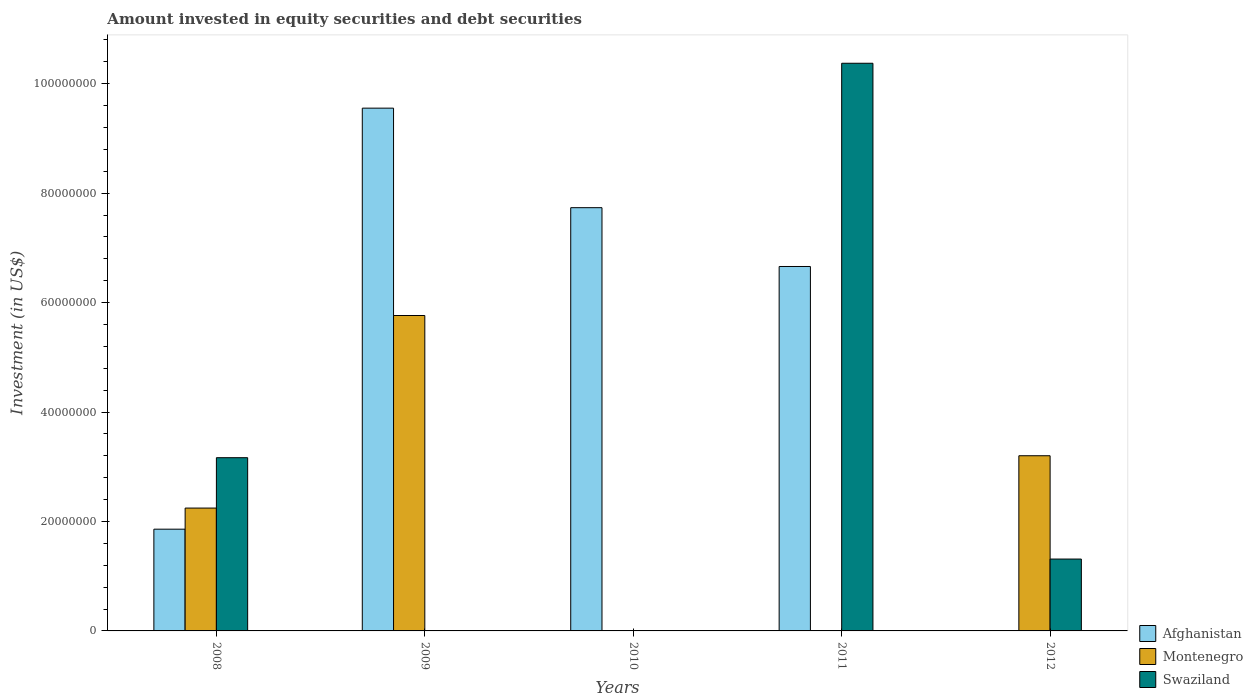How many different coloured bars are there?
Your answer should be very brief. 3. How many bars are there on the 1st tick from the left?
Keep it short and to the point. 3. How many bars are there on the 4th tick from the right?
Offer a terse response. 2. What is the amount invested in equity securities and debt securities in Swaziland in 2011?
Ensure brevity in your answer.  1.04e+08. Across all years, what is the maximum amount invested in equity securities and debt securities in Montenegro?
Ensure brevity in your answer.  5.76e+07. In which year was the amount invested in equity securities and debt securities in Montenegro maximum?
Your response must be concise. 2009. What is the total amount invested in equity securities and debt securities in Swaziland in the graph?
Offer a very short reply. 1.49e+08. What is the difference between the amount invested in equity securities and debt securities in Swaziland in 2008 and that in 2011?
Your response must be concise. -7.21e+07. What is the difference between the amount invested in equity securities and debt securities in Swaziland in 2011 and the amount invested in equity securities and debt securities in Montenegro in 2010?
Make the answer very short. 1.04e+08. What is the average amount invested in equity securities and debt securities in Swaziland per year?
Make the answer very short. 2.97e+07. In the year 2009, what is the difference between the amount invested in equity securities and debt securities in Montenegro and amount invested in equity securities and debt securities in Afghanistan?
Keep it short and to the point. -3.79e+07. What is the ratio of the amount invested in equity securities and debt securities in Swaziland in 2008 to that in 2011?
Give a very brief answer. 0.31. Is the amount invested in equity securities and debt securities in Swaziland in 2011 less than that in 2012?
Make the answer very short. No. Is the difference between the amount invested in equity securities and debt securities in Montenegro in 2008 and 2009 greater than the difference between the amount invested in equity securities and debt securities in Afghanistan in 2008 and 2009?
Give a very brief answer. Yes. What is the difference between the highest and the second highest amount invested in equity securities and debt securities in Swaziland?
Your response must be concise. 7.21e+07. What is the difference between the highest and the lowest amount invested in equity securities and debt securities in Afghanistan?
Your response must be concise. 9.55e+07. Is the sum of the amount invested in equity securities and debt securities in Montenegro in 2009 and 2012 greater than the maximum amount invested in equity securities and debt securities in Afghanistan across all years?
Provide a short and direct response. No. Are the values on the major ticks of Y-axis written in scientific E-notation?
Your answer should be very brief. No. What is the title of the graph?
Your answer should be compact. Amount invested in equity securities and debt securities. What is the label or title of the X-axis?
Make the answer very short. Years. What is the label or title of the Y-axis?
Ensure brevity in your answer.  Investment (in US$). What is the Investment (in US$) in Afghanistan in 2008?
Give a very brief answer. 1.86e+07. What is the Investment (in US$) of Montenegro in 2008?
Offer a very short reply. 2.25e+07. What is the Investment (in US$) in Swaziland in 2008?
Make the answer very short. 3.17e+07. What is the Investment (in US$) of Afghanistan in 2009?
Ensure brevity in your answer.  9.55e+07. What is the Investment (in US$) in Montenegro in 2009?
Provide a succinct answer. 5.76e+07. What is the Investment (in US$) in Afghanistan in 2010?
Ensure brevity in your answer.  7.73e+07. What is the Investment (in US$) of Afghanistan in 2011?
Make the answer very short. 6.66e+07. What is the Investment (in US$) in Swaziland in 2011?
Give a very brief answer. 1.04e+08. What is the Investment (in US$) of Montenegro in 2012?
Offer a very short reply. 3.20e+07. What is the Investment (in US$) of Swaziland in 2012?
Offer a very short reply. 1.31e+07. Across all years, what is the maximum Investment (in US$) in Afghanistan?
Offer a terse response. 9.55e+07. Across all years, what is the maximum Investment (in US$) in Montenegro?
Offer a very short reply. 5.76e+07. Across all years, what is the maximum Investment (in US$) in Swaziland?
Your response must be concise. 1.04e+08. Across all years, what is the minimum Investment (in US$) of Afghanistan?
Ensure brevity in your answer.  0. Across all years, what is the minimum Investment (in US$) in Montenegro?
Keep it short and to the point. 0. Across all years, what is the minimum Investment (in US$) of Swaziland?
Offer a terse response. 0. What is the total Investment (in US$) in Afghanistan in the graph?
Keep it short and to the point. 2.58e+08. What is the total Investment (in US$) in Montenegro in the graph?
Ensure brevity in your answer.  1.12e+08. What is the total Investment (in US$) of Swaziland in the graph?
Your answer should be very brief. 1.49e+08. What is the difference between the Investment (in US$) of Afghanistan in 2008 and that in 2009?
Your answer should be compact. -7.69e+07. What is the difference between the Investment (in US$) of Montenegro in 2008 and that in 2009?
Your response must be concise. -3.52e+07. What is the difference between the Investment (in US$) of Afghanistan in 2008 and that in 2010?
Provide a succinct answer. -5.88e+07. What is the difference between the Investment (in US$) in Afghanistan in 2008 and that in 2011?
Keep it short and to the point. -4.80e+07. What is the difference between the Investment (in US$) in Swaziland in 2008 and that in 2011?
Offer a terse response. -7.21e+07. What is the difference between the Investment (in US$) of Montenegro in 2008 and that in 2012?
Provide a succinct answer. -9.56e+06. What is the difference between the Investment (in US$) of Swaziland in 2008 and that in 2012?
Make the answer very short. 1.85e+07. What is the difference between the Investment (in US$) of Afghanistan in 2009 and that in 2010?
Provide a succinct answer. 1.82e+07. What is the difference between the Investment (in US$) of Afghanistan in 2009 and that in 2011?
Keep it short and to the point. 2.89e+07. What is the difference between the Investment (in US$) in Montenegro in 2009 and that in 2012?
Make the answer very short. 2.56e+07. What is the difference between the Investment (in US$) of Afghanistan in 2010 and that in 2011?
Your response must be concise. 1.07e+07. What is the difference between the Investment (in US$) of Swaziland in 2011 and that in 2012?
Your response must be concise. 9.06e+07. What is the difference between the Investment (in US$) in Afghanistan in 2008 and the Investment (in US$) in Montenegro in 2009?
Your answer should be compact. -3.90e+07. What is the difference between the Investment (in US$) of Afghanistan in 2008 and the Investment (in US$) of Swaziland in 2011?
Your response must be concise. -8.51e+07. What is the difference between the Investment (in US$) in Montenegro in 2008 and the Investment (in US$) in Swaziland in 2011?
Your answer should be very brief. -8.13e+07. What is the difference between the Investment (in US$) of Afghanistan in 2008 and the Investment (in US$) of Montenegro in 2012?
Provide a short and direct response. -1.34e+07. What is the difference between the Investment (in US$) in Afghanistan in 2008 and the Investment (in US$) in Swaziland in 2012?
Keep it short and to the point. 5.46e+06. What is the difference between the Investment (in US$) in Montenegro in 2008 and the Investment (in US$) in Swaziland in 2012?
Offer a terse response. 9.32e+06. What is the difference between the Investment (in US$) in Afghanistan in 2009 and the Investment (in US$) in Swaziland in 2011?
Your answer should be compact. -8.20e+06. What is the difference between the Investment (in US$) in Montenegro in 2009 and the Investment (in US$) in Swaziland in 2011?
Your response must be concise. -4.61e+07. What is the difference between the Investment (in US$) in Afghanistan in 2009 and the Investment (in US$) in Montenegro in 2012?
Make the answer very short. 6.35e+07. What is the difference between the Investment (in US$) of Afghanistan in 2009 and the Investment (in US$) of Swaziland in 2012?
Your answer should be compact. 8.24e+07. What is the difference between the Investment (in US$) of Montenegro in 2009 and the Investment (in US$) of Swaziland in 2012?
Give a very brief answer. 4.45e+07. What is the difference between the Investment (in US$) of Afghanistan in 2010 and the Investment (in US$) of Swaziland in 2011?
Make the answer very short. -2.64e+07. What is the difference between the Investment (in US$) in Afghanistan in 2010 and the Investment (in US$) in Montenegro in 2012?
Provide a succinct answer. 4.53e+07. What is the difference between the Investment (in US$) of Afghanistan in 2010 and the Investment (in US$) of Swaziland in 2012?
Provide a short and direct response. 6.42e+07. What is the difference between the Investment (in US$) of Afghanistan in 2011 and the Investment (in US$) of Montenegro in 2012?
Your answer should be compact. 3.46e+07. What is the difference between the Investment (in US$) in Afghanistan in 2011 and the Investment (in US$) in Swaziland in 2012?
Make the answer very short. 5.35e+07. What is the average Investment (in US$) in Afghanistan per year?
Keep it short and to the point. 5.16e+07. What is the average Investment (in US$) of Montenegro per year?
Make the answer very short. 2.24e+07. What is the average Investment (in US$) of Swaziland per year?
Offer a terse response. 2.97e+07. In the year 2008, what is the difference between the Investment (in US$) in Afghanistan and Investment (in US$) in Montenegro?
Give a very brief answer. -3.86e+06. In the year 2008, what is the difference between the Investment (in US$) in Afghanistan and Investment (in US$) in Swaziland?
Provide a short and direct response. -1.31e+07. In the year 2008, what is the difference between the Investment (in US$) of Montenegro and Investment (in US$) of Swaziland?
Provide a short and direct response. -9.20e+06. In the year 2009, what is the difference between the Investment (in US$) in Afghanistan and Investment (in US$) in Montenegro?
Offer a terse response. 3.79e+07. In the year 2011, what is the difference between the Investment (in US$) of Afghanistan and Investment (in US$) of Swaziland?
Keep it short and to the point. -3.71e+07. In the year 2012, what is the difference between the Investment (in US$) in Montenegro and Investment (in US$) in Swaziland?
Provide a short and direct response. 1.89e+07. What is the ratio of the Investment (in US$) of Afghanistan in 2008 to that in 2009?
Your answer should be compact. 0.19. What is the ratio of the Investment (in US$) in Montenegro in 2008 to that in 2009?
Keep it short and to the point. 0.39. What is the ratio of the Investment (in US$) of Afghanistan in 2008 to that in 2010?
Ensure brevity in your answer.  0.24. What is the ratio of the Investment (in US$) in Afghanistan in 2008 to that in 2011?
Your answer should be very brief. 0.28. What is the ratio of the Investment (in US$) of Swaziland in 2008 to that in 2011?
Keep it short and to the point. 0.31. What is the ratio of the Investment (in US$) in Montenegro in 2008 to that in 2012?
Provide a short and direct response. 0.7. What is the ratio of the Investment (in US$) of Swaziland in 2008 to that in 2012?
Your answer should be compact. 2.41. What is the ratio of the Investment (in US$) of Afghanistan in 2009 to that in 2010?
Make the answer very short. 1.24. What is the ratio of the Investment (in US$) in Afghanistan in 2009 to that in 2011?
Keep it short and to the point. 1.43. What is the ratio of the Investment (in US$) of Montenegro in 2009 to that in 2012?
Provide a short and direct response. 1.8. What is the ratio of the Investment (in US$) in Afghanistan in 2010 to that in 2011?
Offer a terse response. 1.16. What is the ratio of the Investment (in US$) of Swaziland in 2011 to that in 2012?
Ensure brevity in your answer.  7.9. What is the difference between the highest and the second highest Investment (in US$) of Afghanistan?
Offer a terse response. 1.82e+07. What is the difference between the highest and the second highest Investment (in US$) in Montenegro?
Provide a short and direct response. 2.56e+07. What is the difference between the highest and the second highest Investment (in US$) in Swaziland?
Your answer should be compact. 7.21e+07. What is the difference between the highest and the lowest Investment (in US$) in Afghanistan?
Offer a terse response. 9.55e+07. What is the difference between the highest and the lowest Investment (in US$) of Montenegro?
Give a very brief answer. 5.76e+07. What is the difference between the highest and the lowest Investment (in US$) of Swaziland?
Ensure brevity in your answer.  1.04e+08. 